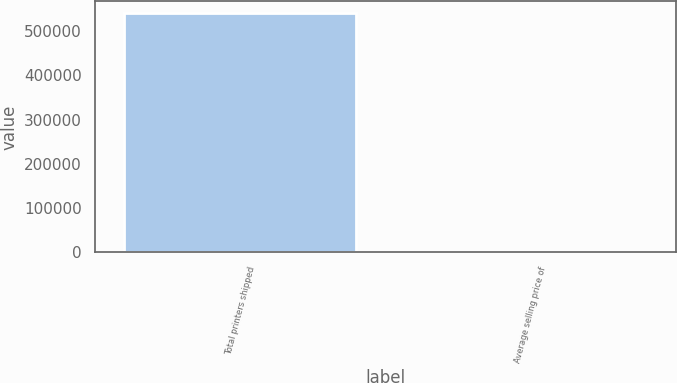Convert chart. <chart><loc_0><loc_0><loc_500><loc_500><bar_chart><fcel>Total printers shipped<fcel>Average selling price of<nl><fcel>540431<fcel>627<nl></chart> 